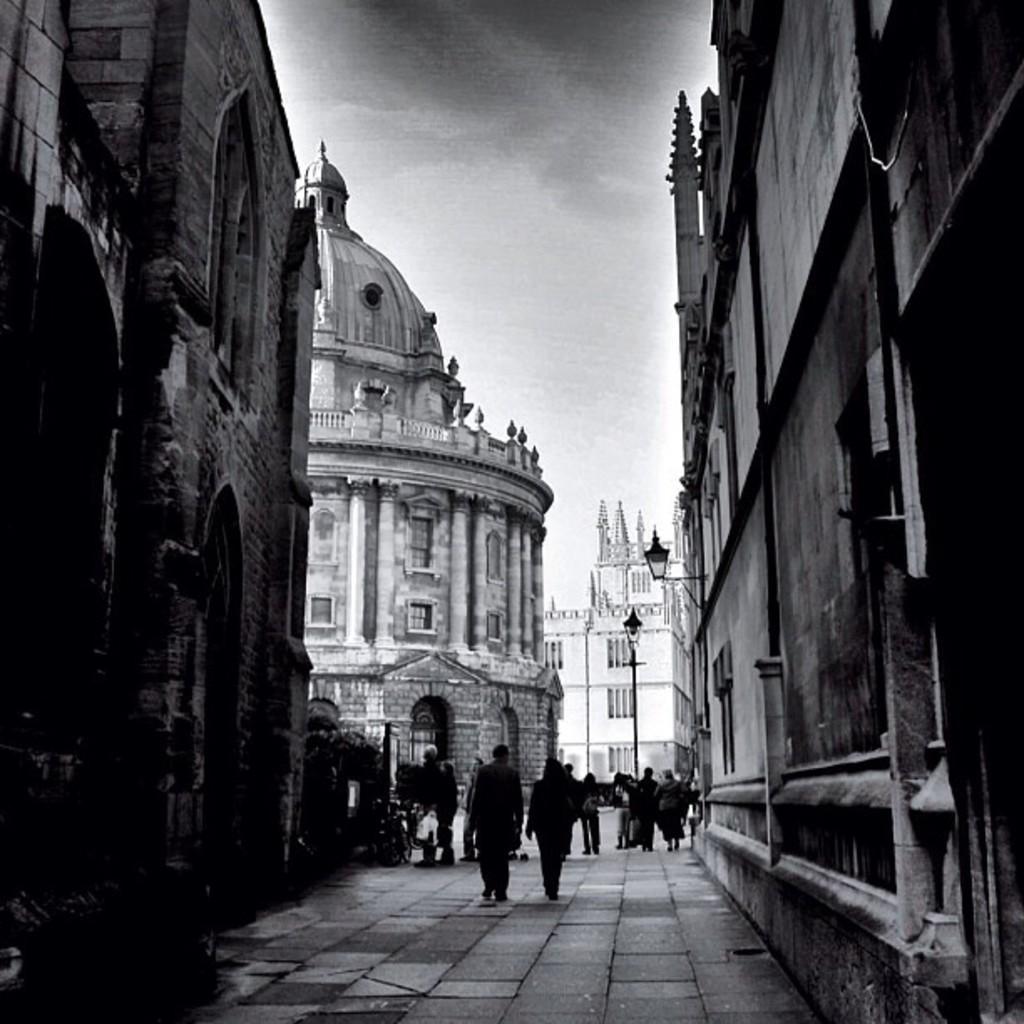Could you give a brief overview of what you see in this image? Black and white picture. In this picture we can see people, buildings, light pole and sky. Lamp is attached to the wall. 